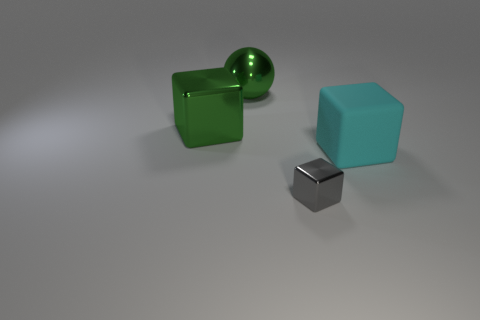How does the lighting in the scene impact the appearance of the objects? The scene's lighting casts soft shadows that accentuate the three-dimensionality of the objects. It creates a slightly diffused reflection on the metal surfaces, highlighting their luster, and gives the colored cubes a vibrant, yet not overly bright, hue, suggesting a diffuse overhead light source. 